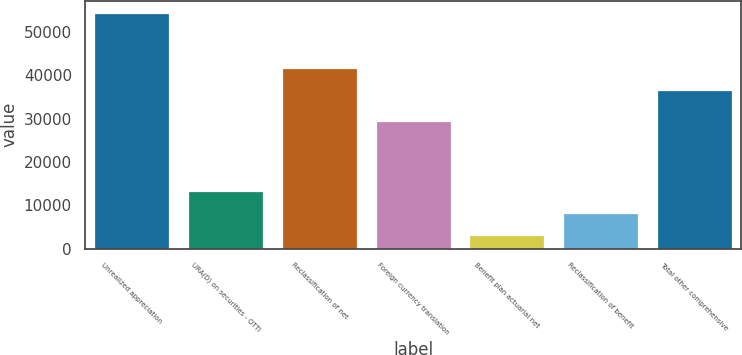Convert chart to OTSL. <chart><loc_0><loc_0><loc_500><loc_500><bar_chart><fcel>Unrealized appreciation<fcel>URA(D) on securities - OTTI<fcel>Reclassification of net<fcel>Foreign currency translation<fcel>Benefit plan actuarial net<fcel>Reclassification of benefit<fcel>Total other comprehensive<nl><fcel>54502<fcel>13347.6<fcel>41722.3<fcel>29388<fcel>3059<fcel>8203.3<fcel>36578<nl></chart> 